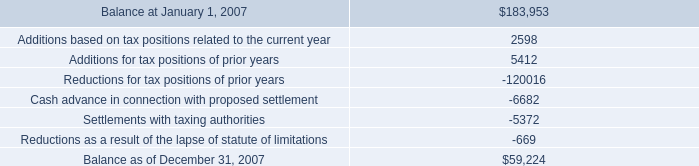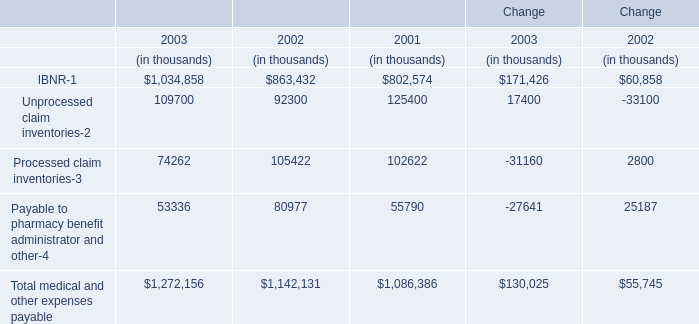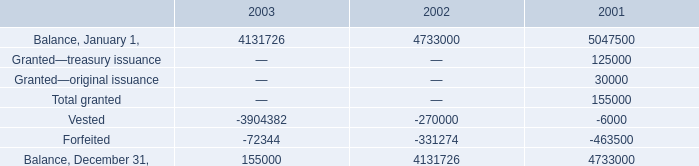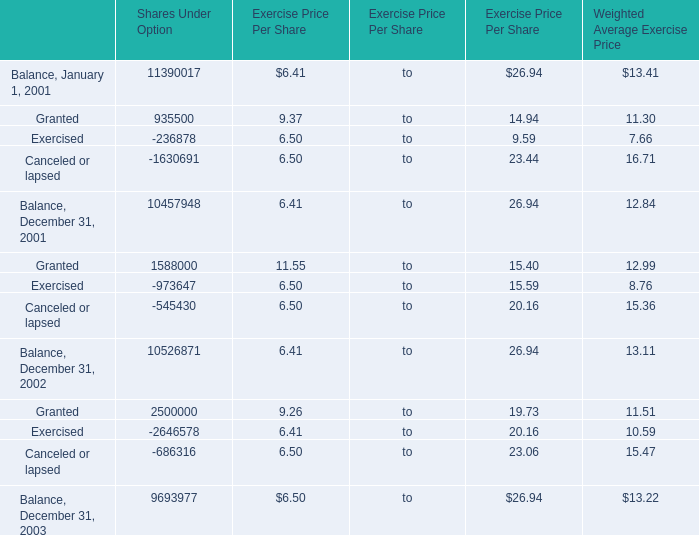What do all Balance sum up, excluding those negative ones in 2002? 
Computations: ((4733000 - 270000) - 331274)
Answer: 4131726.0. 